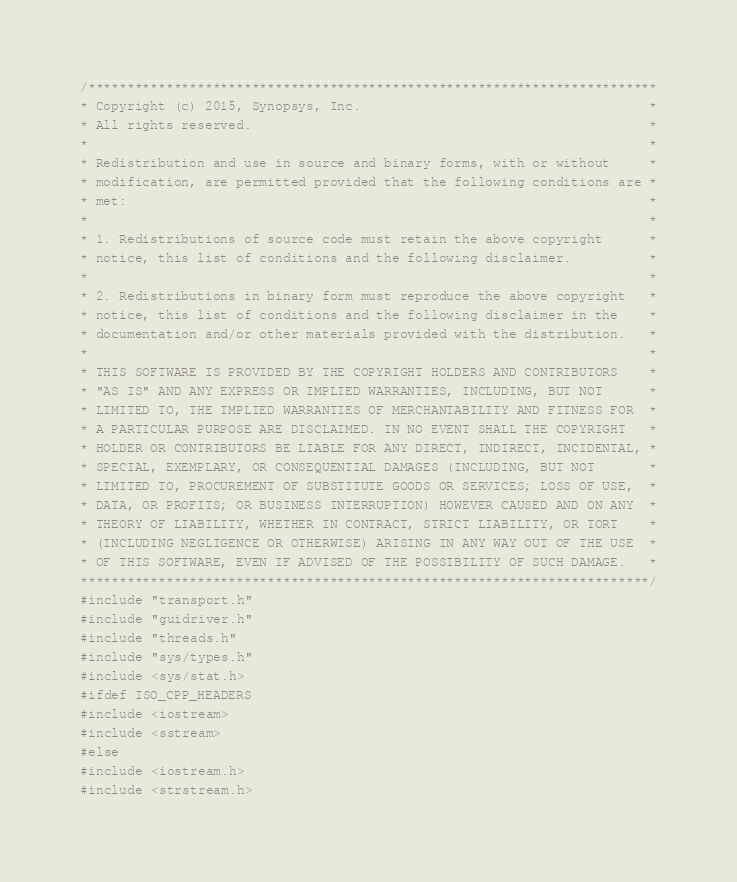Convert code to text. <code><loc_0><loc_0><loc_500><loc_500><_C++_>/*************************************************************************
* Copyright (c) 2015, Synopsys, Inc.                                     *
* All rights reserved.                                                   *
*                                                                        *
* Redistribution and use in source and binary forms, with or without     *
* modification, are permitted provided that the following conditions are *
* met:                                                                   *
*                                                                        *
* 1. Redistributions of source code must retain the above copyright      *
* notice, this list of conditions and the following disclaimer.          *
*                                                                        *
* 2. Redistributions in binary form must reproduce the above copyright   *
* notice, this list of conditions and the following disclaimer in the    *
* documentation and/or other materials provided with the distribution.   *
*                                                                        *
* THIS SOFTWARE IS PROVIDED BY THE COPYRIGHT HOLDERS AND CONTRIBUTORS    *
* "AS IS" AND ANY EXPRESS OR IMPLIED WARRANTIES, INCLUDING, BUT NOT      *
* LIMITED TO, THE IMPLIED WARRANTIES OF MERCHANTABILITY AND FITNESS FOR  *
* A PARTICULAR PURPOSE ARE DISCLAIMED. IN NO EVENT SHALL THE COPYRIGHT   *
* HOLDER OR CONTRIBUTORS BE LIABLE FOR ANY DIRECT, INDIRECT, INCIDENTAL, *
* SPECIAL, EXEMPLARY, OR CONSEQUENTIAL DAMAGES (INCLUDING, BUT NOT       *
* LIMITED TO, PROCUREMENT OF SUBSTITUTE GOODS OR SERVICES; LOSS OF USE,  *
* DATA, OR PROFITS; OR BUSINESS INTERRUPTION) HOWEVER CAUSED AND ON ANY  *
* THEORY OF LIABILITY, WHETHER IN CONTRACT, STRICT LIABILITY, OR TORT    *
* (INCLUDING NEGLIGENCE OR OTHERWISE) ARISING IN ANY WAY OUT OF THE USE  *
* OF THIS SOFTWARE, EVEN IF ADVISED OF THE POSSIBILITY OF SUCH DAMAGE.   *
*************************************************************************/
#include "transport.h"
#include "guidriver.h"
#include "threads.h"
#include "sys/types.h"
#include <sys/stat.h>
#ifdef ISO_CPP_HEADERS
#include <iostream>
#include <sstream>
#else
#include <iostream.h>
#include <strstream.h></code> 